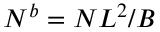<formula> <loc_0><loc_0><loc_500><loc_500>N ^ { b } = N L ^ { 2 } / B</formula> 